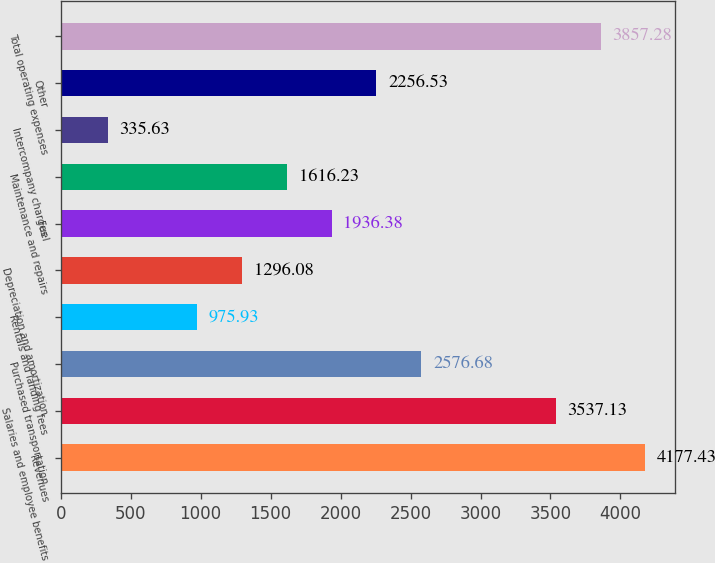<chart> <loc_0><loc_0><loc_500><loc_500><bar_chart><fcel>Revenues<fcel>Salaries and employee benefits<fcel>Purchased transportation<fcel>Rentals and landing fees<fcel>Depreciation and amortization<fcel>Fuel<fcel>Maintenance and repairs<fcel>Intercompany charges<fcel>Other<fcel>Total operating expenses<nl><fcel>4177.43<fcel>3537.13<fcel>2576.68<fcel>975.93<fcel>1296.08<fcel>1936.38<fcel>1616.23<fcel>335.63<fcel>2256.53<fcel>3857.28<nl></chart> 